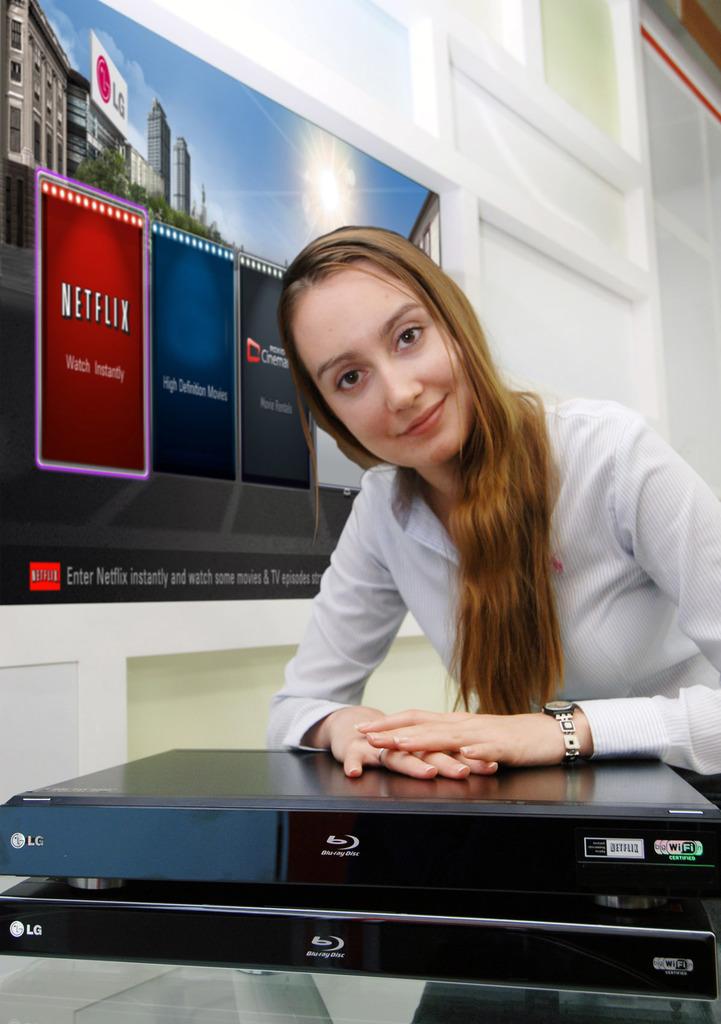Who is the manufacturer of the blu0ray players?
Your answer should be very brief. Lg. 